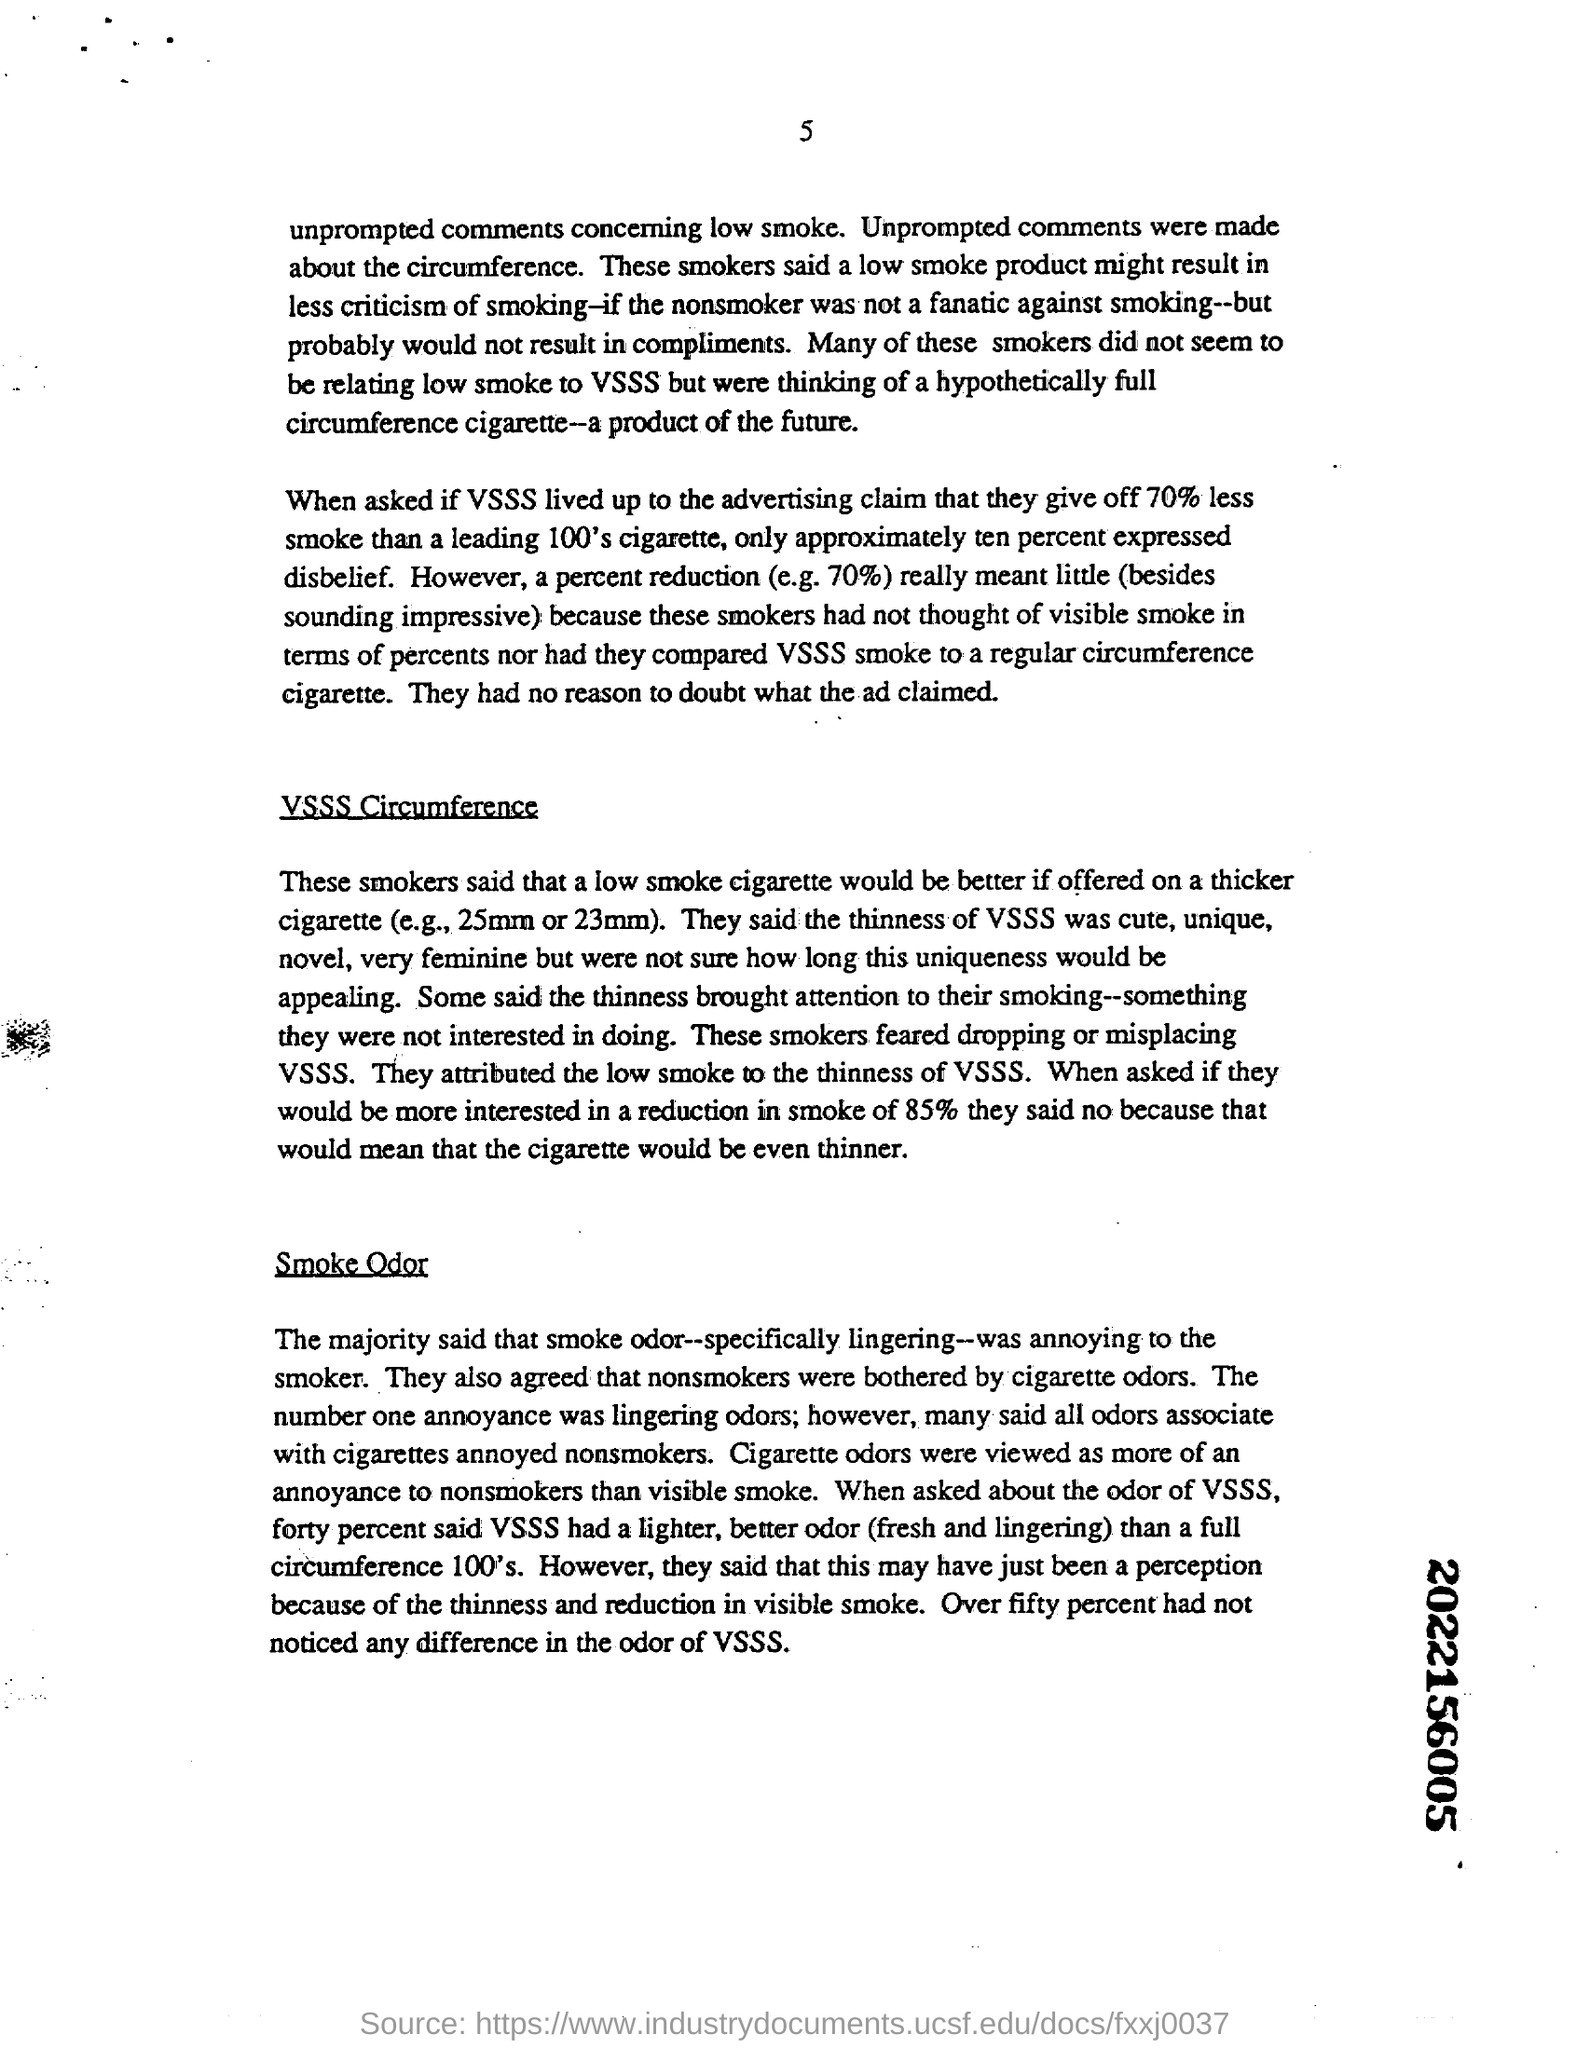Which cigarette would be better if offered on a thicker cigarette
Keep it short and to the point. Low smoke cigarette. How much percent had not noticed any difference in the odor of VSSS
Offer a terse response. Over Fifty percent. Who were bothered by cigarette odors
Give a very brief answer. Nonsmokers. 